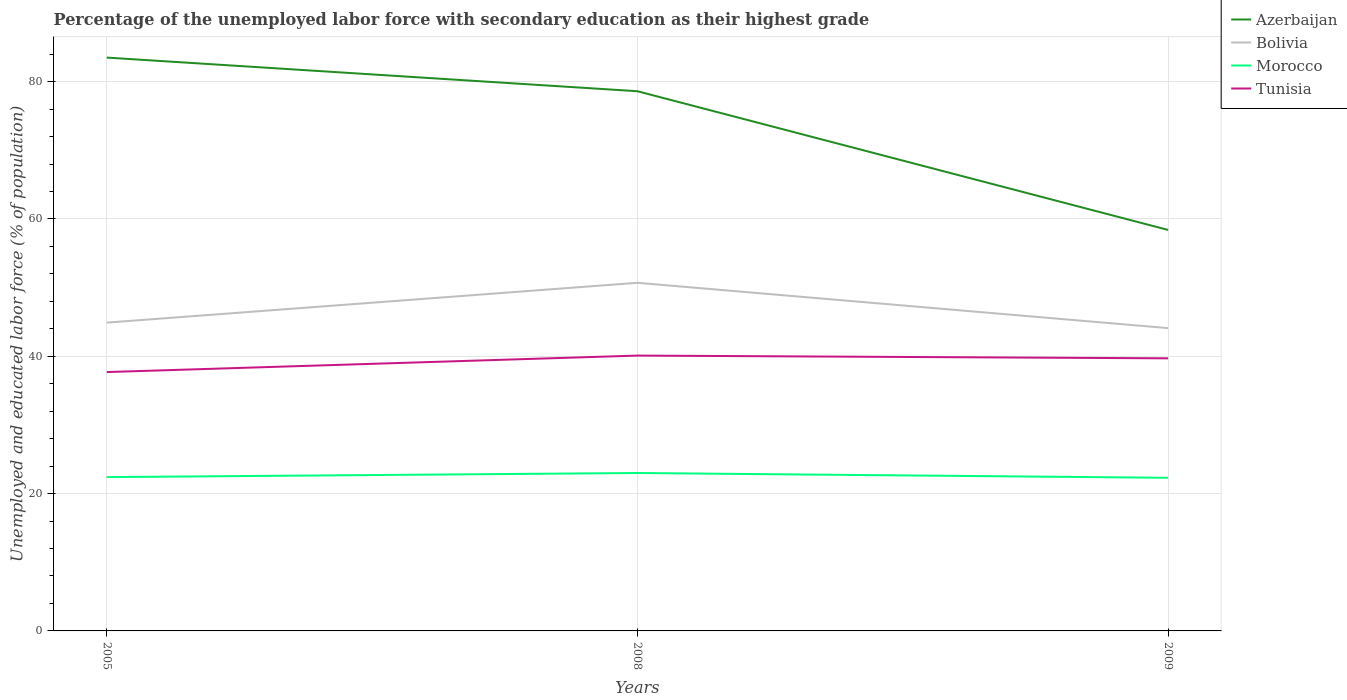Is the number of lines equal to the number of legend labels?
Keep it short and to the point. Yes. Across all years, what is the maximum percentage of the unemployed labor force with secondary education in Morocco?
Make the answer very short. 22.3. What is the total percentage of the unemployed labor force with secondary education in Bolivia in the graph?
Keep it short and to the point. -5.8. What is the difference between the highest and the second highest percentage of the unemployed labor force with secondary education in Morocco?
Provide a succinct answer. 0.7. How many years are there in the graph?
Make the answer very short. 3. Does the graph contain grids?
Your answer should be very brief. Yes. How many legend labels are there?
Provide a succinct answer. 4. What is the title of the graph?
Give a very brief answer. Percentage of the unemployed labor force with secondary education as their highest grade. What is the label or title of the X-axis?
Give a very brief answer. Years. What is the label or title of the Y-axis?
Offer a very short reply. Unemployed and educated labor force (% of population). What is the Unemployed and educated labor force (% of population) in Azerbaijan in 2005?
Provide a short and direct response. 83.5. What is the Unemployed and educated labor force (% of population) in Bolivia in 2005?
Keep it short and to the point. 44.9. What is the Unemployed and educated labor force (% of population) of Morocco in 2005?
Your answer should be compact. 22.4. What is the Unemployed and educated labor force (% of population) of Tunisia in 2005?
Your response must be concise. 37.7. What is the Unemployed and educated labor force (% of population) of Azerbaijan in 2008?
Keep it short and to the point. 78.6. What is the Unemployed and educated labor force (% of population) of Bolivia in 2008?
Provide a short and direct response. 50.7. What is the Unemployed and educated labor force (% of population) of Morocco in 2008?
Offer a very short reply. 23. What is the Unemployed and educated labor force (% of population) in Tunisia in 2008?
Your answer should be compact. 40.1. What is the Unemployed and educated labor force (% of population) in Azerbaijan in 2009?
Provide a short and direct response. 58.4. What is the Unemployed and educated labor force (% of population) of Bolivia in 2009?
Ensure brevity in your answer.  44.1. What is the Unemployed and educated labor force (% of population) of Morocco in 2009?
Keep it short and to the point. 22.3. What is the Unemployed and educated labor force (% of population) in Tunisia in 2009?
Provide a succinct answer. 39.7. Across all years, what is the maximum Unemployed and educated labor force (% of population) in Azerbaijan?
Offer a very short reply. 83.5. Across all years, what is the maximum Unemployed and educated labor force (% of population) of Bolivia?
Keep it short and to the point. 50.7. Across all years, what is the maximum Unemployed and educated labor force (% of population) in Morocco?
Your response must be concise. 23. Across all years, what is the maximum Unemployed and educated labor force (% of population) of Tunisia?
Keep it short and to the point. 40.1. Across all years, what is the minimum Unemployed and educated labor force (% of population) in Azerbaijan?
Provide a succinct answer. 58.4. Across all years, what is the minimum Unemployed and educated labor force (% of population) in Bolivia?
Your response must be concise. 44.1. Across all years, what is the minimum Unemployed and educated labor force (% of population) of Morocco?
Offer a very short reply. 22.3. Across all years, what is the minimum Unemployed and educated labor force (% of population) in Tunisia?
Offer a terse response. 37.7. What is the total Unemployed and educated labor force (% of population) in Azerbaijan in the graph?
Keep it short and to the point. 220.5. What is the total Unemployed and educated labor force (% of population) of Bolivia in the graph?
Ensure brevity in your answer.  139.7. What is the total Unemployed and educated labor force (% of population) of Morocco in the graph?
Give a very brief answer. 67.7. What is the total Unemployed and educated labor force (% of population) in Tunisia in the graph?
Offer a very short reply. 117.5. What is the difference between the Unemployed and educated labor force (% of population) in Azerbaijan in 2005 and that in 2009?
Provide a short and direct response. 25.1. What is the difference between the Unemployed and educated labor force (% of population) of Bolivia in 2005 and that in 2009?
Keep it short and to the point. 0.8. What is the difference between the Unemployed and educated labor force (% of population) of Tunisia in 2005 and that in 2009?
Your response must be concise. -2. What is the difference between the Unemployed and educated labor force (% of population) of Azerbaijan in 2008 and that in 2009?
Ensure brevity in your answer.  20.2. What is the difference between the Unemployed and educated labor force (% of population) of Bolivia in 2008 and that in 2009?
Provide a succinct answer. 6.6. What is the difference between the Unemployed and educated labor force (% of population) in Morocco in 2008 and that in 2009?
Your response must be concise. 0.7. What is the difference between the Unemployed and educated labor force (% of population) of Tunisia in 2008 and that in 2009?
Make the answer very short. 0.4. What is the difference between the Unemployed and educated labor force (% of population) in Azerbaijan in 2005 and the Unemployed and educated labor force (% of population) in Bolivia in 2008?
Provide a short and direct response. 32.8. What is the difference between the Unemployed and educated labor force (% of population) of Azerbaijan in 2005 and the Unemployed and educated labor force (% of population) of Morocco in 2008?
Your answer should be compact. 60.5. What is the difference between the Unemployed and educated labor force (% of population) of Azerbaijan in 2005 and the Unemployed and educated labor force (% of population) of Tunisia in 2008?
Offer a terse response. 43.4. What is the difference between the Unemployed and educated labor force (% of population) of Bolivia in 2005 and the Unemployed and educated labor force (% of population) of Morocco in 2008?
Provide a short and direct response. 21.9. What is the difference between the Unemployed and educated labor force (% of population) in Bolivia in 2005 and the Unemployed and educated labor force (% of population) in Tunisia in 2008?
Offer a terse response. 4.8. What is the difference between the Unemployed and educated labor force (% of population) in Morocco in 2005 and the Unemployed and educated labor force (% of population) in Tunisia in 2008?
Your answer should be compact. -17.7. What is the difference between the Unemployed and educated labor force (% of population) in Azerbaijan in 2005 and the Unemployed and educated labor force (% of population) in Bolivia in 2009?
Keep it short and to the point. 39.4. What is the difference between the Unemployed and educated labor force (% of population) of Azerbaijan in 2005 and the Unemployed and educated labor force (% of population) of Morocco in 2009?
Provide a succinct answer. 61.2. What is the difference between the Unemployed and educated labor force (% of population) in Azerbaijan in 2005 and the Unemployed and educated labor force (% of population) in Tunisia in 2009?
Offer a terse response. 43.8. What is the difference between the Unemployed and educated labor force (% of population) in Bolivia in 2005 and the Unemployed and educated labor force (% of population) in Morocco in 2009?
Make the answer very short. 22.6. What is the difference between the Unemployed and educated labor force (% of population) of Morocco in 2005 and the Unemployed and educated labor force (% of population) of Tunisia in 2009?
Make the answer very short. -17.3. What is the difference between the Unemployed and educated labor force (% of population) in Azerbaijan in 2008 and the Unemployed and educated labor force (% of population) in Bolivia in 2009?
Your answer should be compact. 34.5. What is the difference between the Unemployed and educated labor force (% of population) in Azerbaijan in 2008 and the Unemployed and educated labor force (% of population) in Morocco in 2009?
Ensure brevity in your answer.  56.3. What is the difference between the Unemployed and educated labor force (% of population) of Azerbaijan in 2008 and the Unemployed and educated labor force (% of population) of Tunisia in 2009?
Give a very brief answer. 38.9. What is the difference between the Unemployed and educated labor force (% of population) in Bolivia in 2008 and the Unemployed and educated labor force (% of population) in Morocco in 2009?
Offer a terse response. 28.4. What is the difference between the Unemployed and educated labor force (% of population) of Bolivia in 2008 and the Unemployed and educated labor force (% of population) of Tunisia in 2009?
Give a very brief answer. 11. What is the difference between the Unemployed and educated labor force (% of population) of Morocco in 2008 and the Unemployed and educated labor force (% of population) of Tunisia in 2009?
Your answer should be very brief. -16.7. What is the average Unemployed and educated labor force (% of population) in Azerbaijan per year?
Make the answer very short. 73.5. What is the average Unemployed and educated labor force (% of population) of Bolivia per year?
Your answer should be very brief. 46.57. What is the average Unemployed and educated labor force (% of population) of Morocco per year?
Offer a terse response. 22.57. What is the average Unemployed and educated labor force (% of population) of Tunisia per year?
Ensure brevity in your answer.  39.17. In the year 2005, what is the difference between the Unemployed and educated labor force (% of population) in Azerbaijan and Unemployed and educated labor force (% of population) in Bolivia?
Your response must be concise. 38.6. In the year 2005, what is the difference between the Unemployed and educated labor force (% of population) in Azerbaijan and Unemployed and educated labor force (% of population) in Morocco?
Your answer should be very brief. 61.1. In the year 2005, what is the difference between the Unemployed and educated labor force (% of population) of Azerbaijan and Unemployed and educated labor force (% of population) of Tunisia?
Ensure brevity in your answer.  45.8. In the year 2005, what is the difference between the Unemployed and educated labor force (% of population) of Bolivia and Unemployed and educated labor force (% of population) of Tunisia?
Give a very brief answer. 7.2. In the year 2005, what is the difference between the Unemployed and educated labor force (% of population) in Morocco and Unemployed and educated labor force (% of population) in Tunisia?
Keep it short and to the point. -15.3. In the year 2008, what is the difference between the Unemployed and educated labor force (% of population) of Azerbaijan and Unemployed and educated labor force (% of population) of Bolivia?
Offer a very short reply. 27.9. In the year 2008, what is the difference between the Unemployed and educated labor force (% of population) of Azerbaijan and Unemployed and educated labor force (% of population) of Morocco?
Your response must be concise. 55.6. In the year 2008, what is the difference between the Unemployed and educated labor force (% of population) of Azerbaijan and Unemployed and educated labor force (% of population) of Tunisia?
Provide a short and direct response. 38.5. In the year 2008, what is the difference between the Unemployed and educated labor force (% of population) in Bolivia and Unemployed and educated labor force (% of population) in Morocco?
Provide a short and direct response. 27.7. In the year 2008, what is the difference between the Unemployed and educated labor force (% of population) of Morocco and Unemployed and educated labor force (% of population) of Tunisia?
Your answer should be very brief. -17.1. In the year 2009, what is the difference between the Unemployed and educated labor force (% of population) in Azerbaijan and Unemployed and educated labor force (% of population) in Bolivia?
Make the answer very short. 14.3. In the year 2009, what is the difference between the Unemployed and educated labor force (% of population) in Azerbaijan and Unemployed and educated labor force (% of population) in Morocco?
Provide a short and direct response. 36.1. In the year 2009, what is the difference between the Unemployed and educated labor force (% of population) of Bolivia and Unemployed and educated labor force (% of population) of Morocco?
Keep it short and to the point. 21.8. In the year 2009, what is the difference between the Unemployed and educated labor force (% of population) of Bolivia and Unemployed and educated labor force (% of population) of Tunisia?
Give a very brief answer. 4.4. In the year 2009, what is the difference between the Unemployed and educated labor force (% of population) of Morocco and Unemployed and educated labor force (% of population) of Tunisia?
Your response must be concise. -17.4. What is the ratio of the Unemployed and educated labor force (% of population) of Azerbaijan in 2005 to that in 2008?
Keep it short and to the point. 1.06. What is the ratio of the Unemployed and educated labor force (% of population) of Bolivia in 2005 to that in 2008?
Keep it short and to the point. 0.89. What is the ratio of the Unemployed and educated labor force (% of population) of Morocco in 2005 to that in 2008?
Ensure brevity in your answer.  0.97. What is the ratio of the Unemployed and educated labor force (% of population) of Tunisia in 2005 to that in 2008?
Your answer should be compact. 0.94. What is the ratio of the Unemployed and educated labor force (% of population) in Azerbaijan in 2005 to that in 2009?
Ensure brevity in your answer.  1.43. What is the ratio of the Unemployed and educated labor force (% of population) in Bolivia in 2005 to that in 2009?
Provide a succinct answer. 1.02. What is the ratio of the Unemployed and educated labor force (% of population) of Tunisia in 2005 to that in 2009?
Provide a succinct answer. 0.95. What is the ratio of the Unemployed and educated labor force (% of population) in Azerbaijan in 2008 to that in 2009?
Keep it short and to the point. 1.35. What is the ratio of the Unemployed and educated labor force (% of population) in Bolivia in 2008 to that in 2009?
Provide a short and direct response. 1.15. What is the ratio of the Unemployed and educated labor force (% of population) in Morocco in 2008 to that in 2009?
Keep it short and to the point. 1.03. What is the difference between the highest and the second highest Unemployed and educated labor force (% of population) of Azerbaijan?
Provide a succinct answer. 4.9. What is the difference between the highest and the second highest Unemployed and educated labor force (% of population) in Bolivia?
Your answer should be compact. 5.8. What is the difference between the highest and the lowest Unemployed and educated labor force (% of population) in Azerbaijan?
Provide a succinct answer. 25.1. What is the difference between the highest and the lowest Unemployed and educated labor force (% of population) of Morocco?
Offer a terse response. 0.7. What is the difference between the highest and the lowest Unemployed and educated labor force (% of population) of Tunisia?
Ensure brevity in your answer.  2.4. 